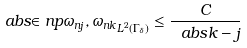Convert formula to latex. <formula><loc_0><loc_0><loc_500><loc_500>a b s { \in n p { \omega _ { n j } , \omega _ { n k } } _ { L ^ { 2 } ( \Gamma _ { \delta } ) } } \leq \frac { C } { \ a b s { k - j } }</formula> 